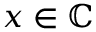<formula> <loc_0><loc_0><loc_500><loc_500>x \in \mathbb { C }</formula> 